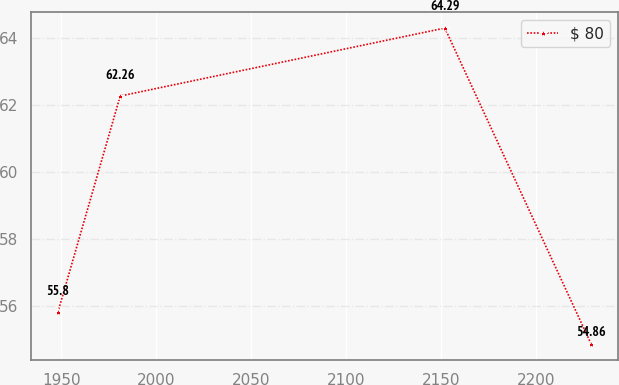<chart> <loc_0><loc_0><loc_500><loc_500><line_chart><ecel><fcel>$ 80<nl><fcel>1948.11<fcel>55.8<nl><fcel>1980.98<fcel>62.26<nl><fcel>2152.09<fcel>64.29<nl><fcel>2229.17<fcel>54.86<nl></chart> 